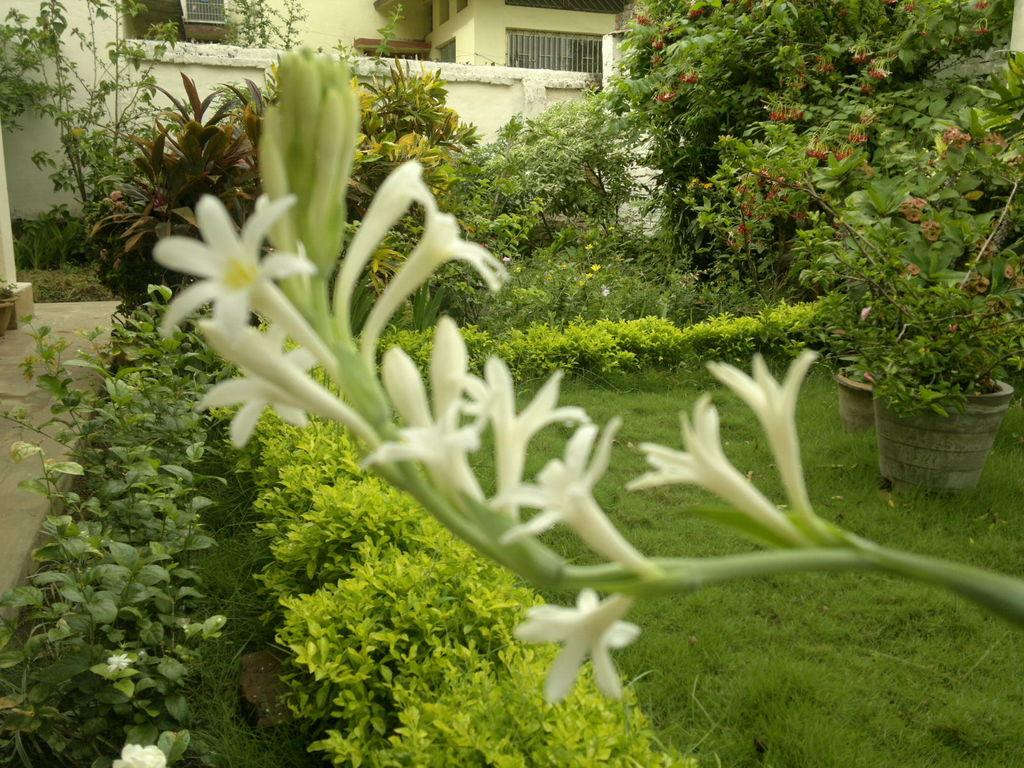What type of flowers are on the stem in the image? There are white color flowers on a stem in the image. What can be seen in the background of the image? There are flowering plants, a grass lawn, and a wall in the background. What type of containers are present in the image? There are pots with plants in the image. What type of structure is visible in the background? There is a building in the background. What type of cushion is placed on top of the building in the image? There is no cushion present on top of the building in the image. 